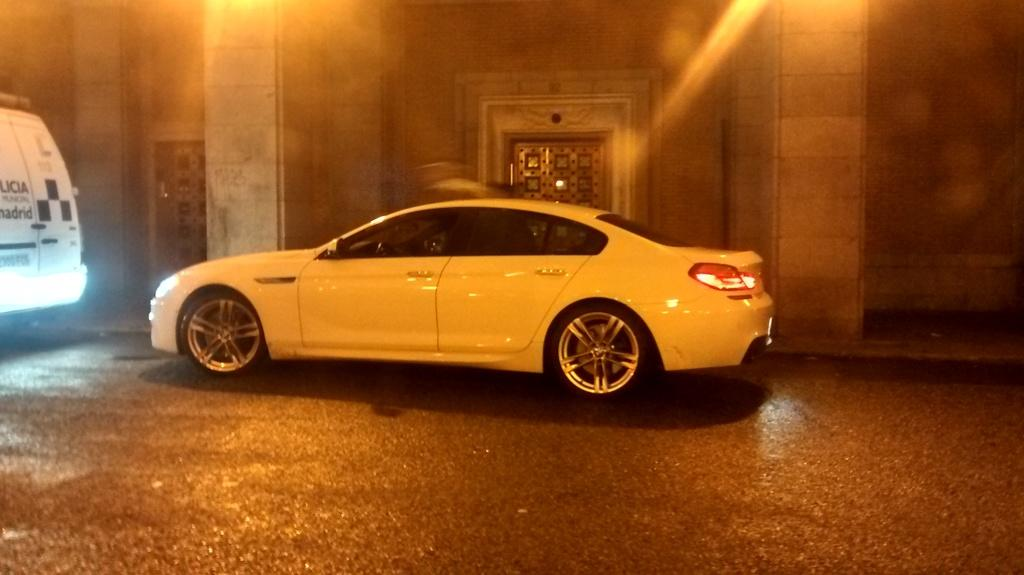What is the main subject of the image? There is a car in the image. Can you describe the position of the other vehicle in relation to the car? There is another vehicle in front of the car. What architectural features are visible behind the car? There are pillars behind the car. How many doors are visible behind the pillars? There are two doors behind the pillars. What type of popcorn is being served in the image? There is no popcorn present in the image. How many fangs can be seen on the car in the image? Cars do not have fangs, so this question cannot be answered based on the image. 